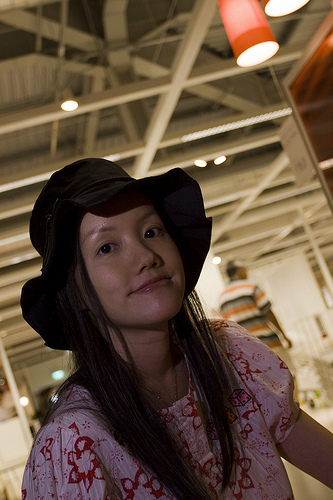<image>
Is there a girl under the light? Yes. The girl is positioned underneath the light, with the light above it in the vertical space. 